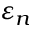<formula> <loc_0><loc_0><loc_500><loc_500>\varepsilon _ { n }</formula> 